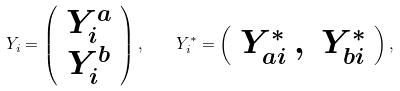<formula> <loc_0><loc_0><loc_500><loc_500>Y _ { i } = \left ( \begin{array} { c } Y _ { i } ^ { a } \\ Y _ { i } ^ { b } \end{array} \right ) , \quad Y _ { i } ^ { * } = \left ( \begin{array} { c c } Y _ { a i } ^ { * } \, , & Y _ { b i } ^ { * } \end{array} \right ) ,</formula> 